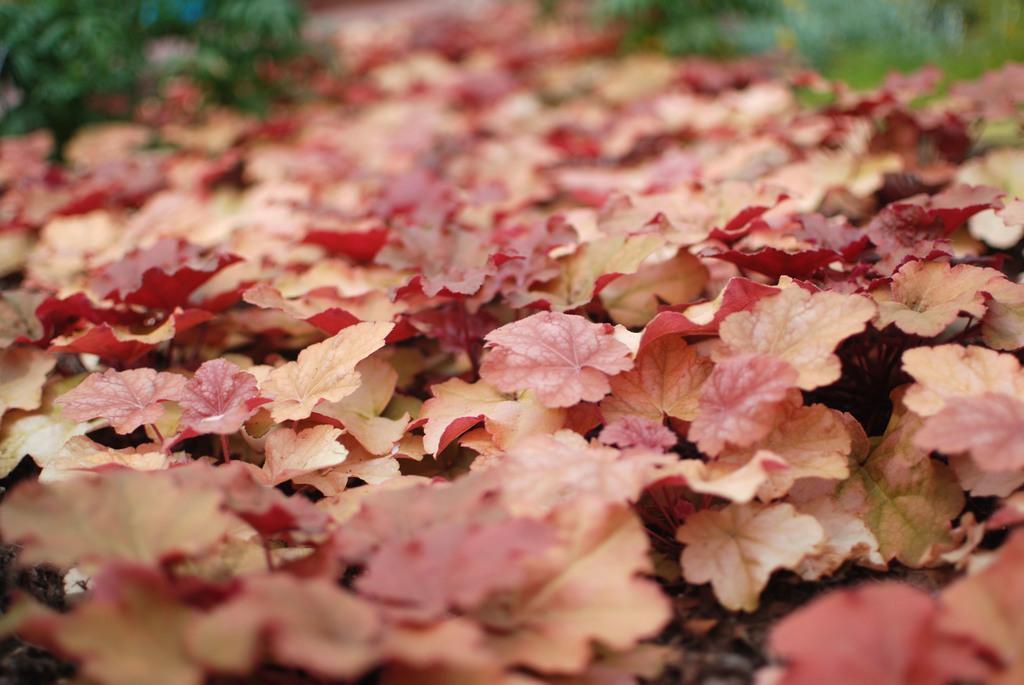Describe this image in one or two sentences. In this image we can see some plants. 